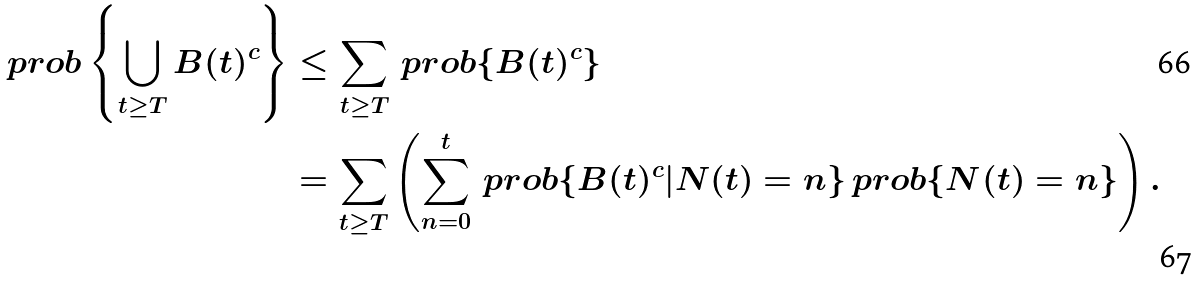<formula> <loc_0><loc_0><loc_500><loc_500>\ p r o b \left \{ \bigcup _ { t \geq T } B ( t ) ^ { c } \right \} & \leq \sum _ { t \geq T } \ p r o b \{ B ( t ) ^ { c } \} \\ & = \sum _ { t \geq T } \left ( \sum _ { n = 0 } ^ { t } \ p r o b \{ B ( t ) ^ { c } | N ( t ) = n \} \ p r o b \{ N ( t ) = n \} \right ) .</formula> 